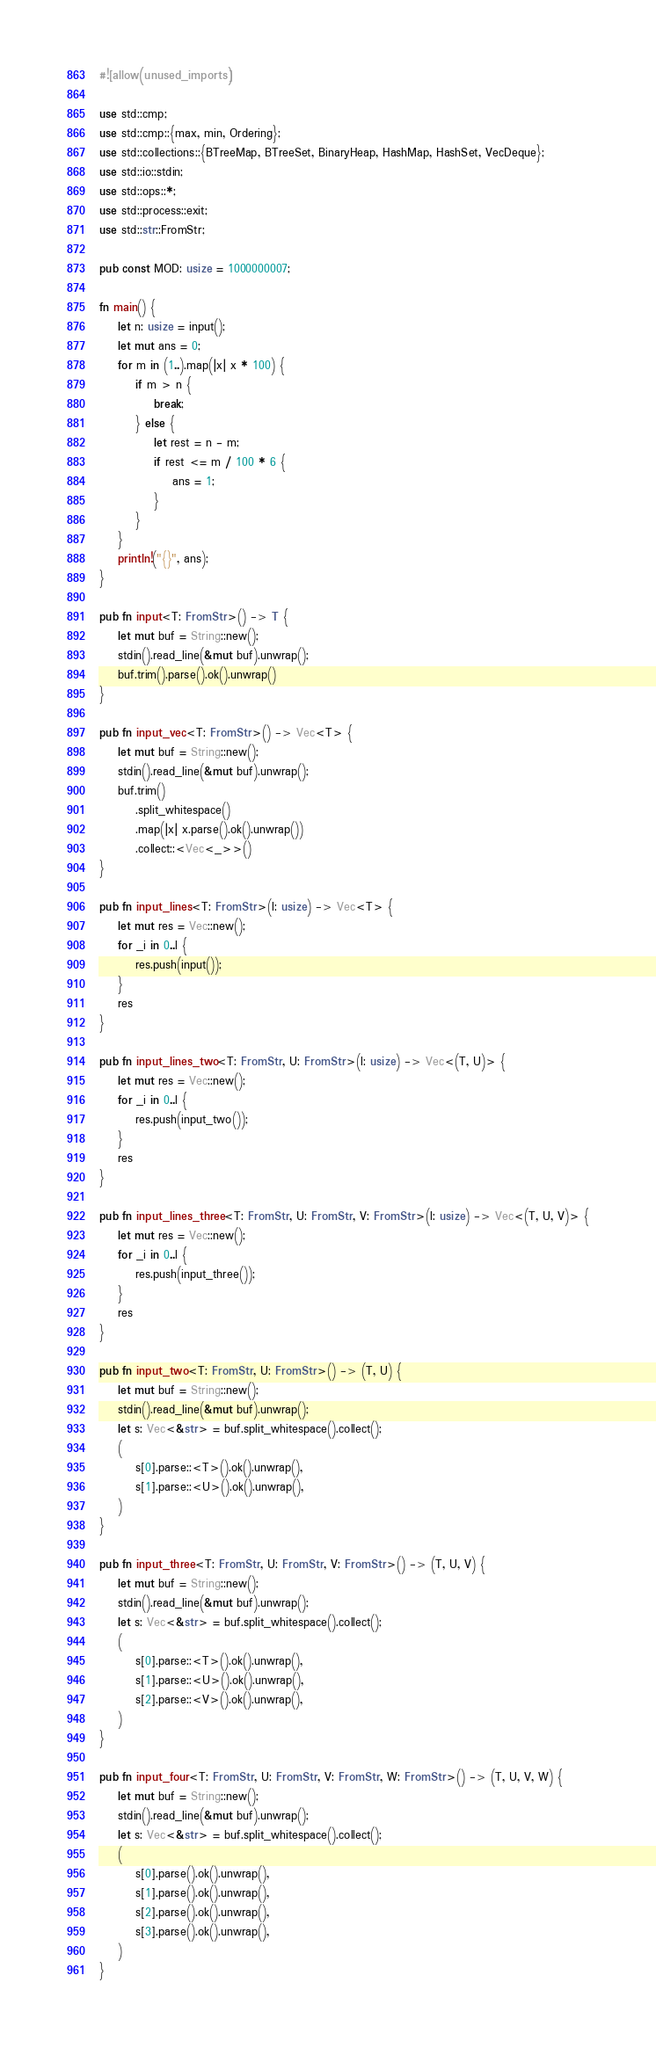Convert code to text. <code><loc_0><loc_0><loc_500><loc_500><_Rust_>#![allow(unused_imports)]

use std::cmp;
use std::cmp::{max, min, Ordering};
use std::collections::{BTreeMap, BTreeSet, BinaryHeap, HashMap, HashSet, VecDeque};
use std::io::stdin;
use std::ops::*;
use std::process::exit;
use std::str::FromStr;

pub const MOD: usize = 1000000007;

fn main() {
    let n: usize = input();
    let mut ans = 0;
    for m in (1..).map(|x| x * 100) {
        if m > n {
            break;
        } else {
            let rest = n - m;
            if rest <= m / 100 * 6 {
                ans = 1;
            }
        }
    }
    println!("{}", ans);
}

pub fn input<T: FromStr>() -> T {
    let mut buf = String::new();
    stdin().read_line(&mut buf).unwrap();
    buf.trim().parse().ok().unwrap()
}

pub fn input_vec<T: FromStr>() -> Vec<T> {
    let mut buf = String::new();
    stdin().read_line(&mut buf).unwrap();
    buf.trim()
        .split_whitespace()
        .map(|x| x.parse().ok().unwrap())
        .collect::<Vec<_>>()
}

pub fn input_lines<T: FromStr>(l: usize) -> Vec<T> {
    let mut res = Vec::new();
    for _i in 0..l {
        res.push(input());
    }
    res
}

pub fn input_lines_two<T: FromStr, U: FromStr>(l: usize) -> Vec<(T, U)> {
    let mut res = Vec::new();
    for _i in 0..l {
        res.push(input_two());
    }
    res
}

pub fn input_lines_three<T: FromStr, U: FromStr, V: FromStr>(l: usize) -> Vec<(T, U, V)> {
    let mut res = Vec::new();
    for _i in 0..l {
        res.push(input_three());
    }
    res
}

pub fn input_two<T: FromStr, U: FromStr>() -> (T, U) {
    let mut buf = String::new();
    stdin().read_line(&mut buf).unwrap();
    let s: Vec<&str> = buf.split_whitespace().collect();
    (
        s[0].parse::<T>().ok().unwrap(),
        s[1].parse::<U>().ok().unwrap(),
    )
}

pub fn input_three<T: FromStr, U: FromStr, V: FromStr>() -> (T, U, V) {
    let mut buf = String::new();
    stdin().read_line(&mut buf).unwrap();
    let s: Vec<&str> = buf.split_whitespace().collect();
    (
        s[0].parse::<T>().ok().unwrap(),
        s[1].parse::<U>().ok().unwrap(),
        s[2].parse::<V>().ok().unwrap(),
    )
}

pub fn input_four<T: FromStr, U: FromStr, V: FromStr, W: FromStr>() -> (T, U, V, W) {
    let mut buf = String::new();
    stdin().read_line(&mut buf).unwrap();
    let s: Vec<&str> = buf.split_whitespace().collect();
    (
        s[0].parse().ok().unwrap(),
        s[1].parse().ok().unwrap(),
        s[2].parse().ok().unwrap(),
        s[3].parse().ok().unwrap(),
    )
}
</code> 